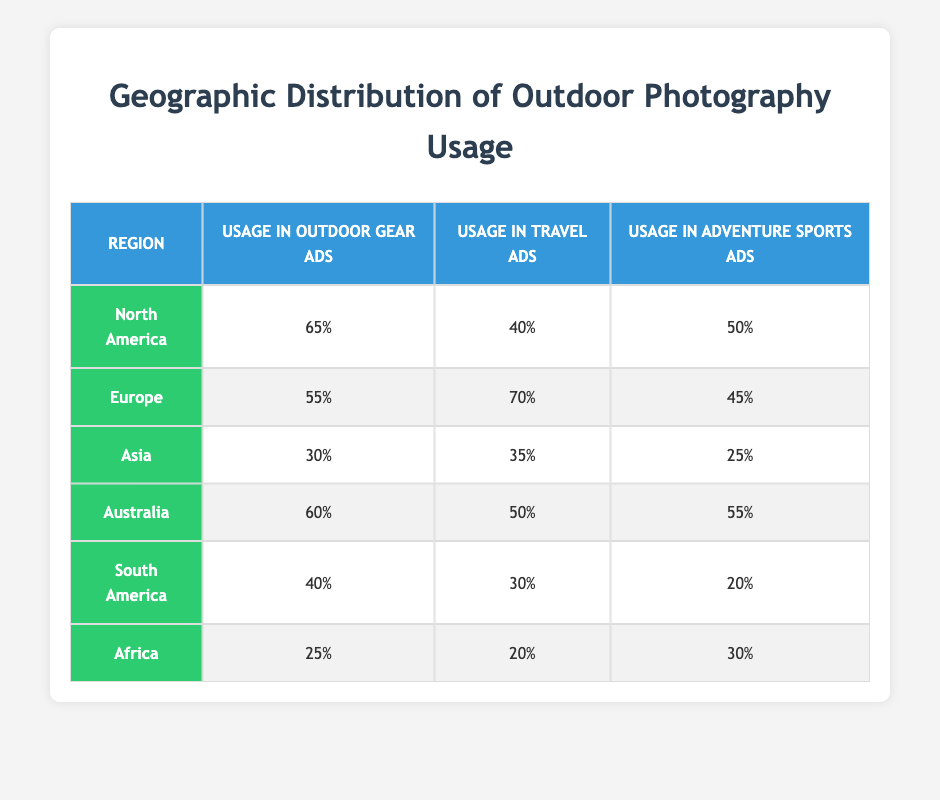What region has the highest usage in Outdoor Gear Ads? Looking at the column for "Usage in Outdoor Gear Ads," North America has the highest value of 65, which is greater than all other regions listed.
Answer: North America Which region has the lowest usage in Travel Ads? In the "Usage in Travel Ads" column, Africa has the lowest value of 20, compared to other regions which have higher values.
Answer: Africa What is the average usage in Adventure Sports Ads across all regions? To find the average, we sum the values across the "Usage in Adventure Sports Ads" column: 50 + 45 + 25 + 55 + 20 + 30 = 225. There are 6 regions, so the average is 225 divided by 6, which equals 37.5.
Answer: 37.5 Is the usage in Outdoor Gear Ads for Europe greater than that for Asia? Comparing the "Usage in Outdoor Gear Ads" values for Europe (55) and Asia (30), we see that Europe has a higher value.
Answer: Yes Which region has a higher usage in Travel Ads: North America or Australia? North America has a value of 40 in "Usage in Travel Ads" while Australia has a value of 50. Since 50 is greater than 40, Australia has a higher usage.
Answer: Australia 